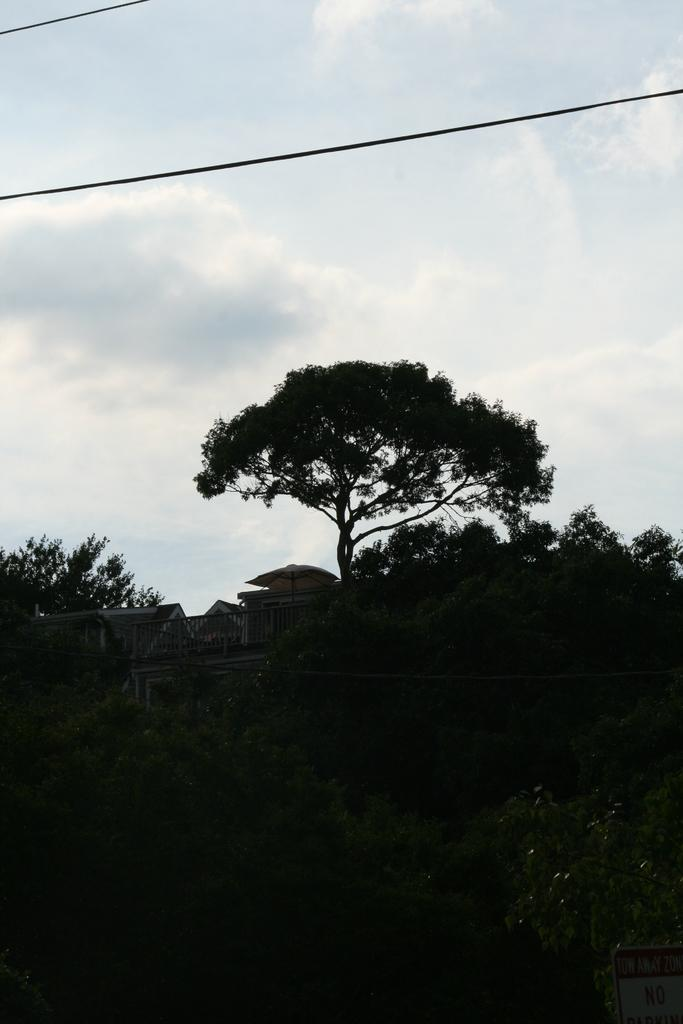What type of vegetation is present in the image? There are green color plants and trees in the image. What type of structures can be seen in the image? There are homes in the image. What is visible in the background of the image? The sky is visible in the image. What is the condition of the sky in the image? The sky is cloudy in the image. What type of party or club is depicted in the image? There is no party or club present in the image; it features green plants, trees, homes, and a cloudy sky. What type of suit is being worn by the trees in the image? There are no suits present in the image; it features green plants, trees, homes, and a cloudy sky. 